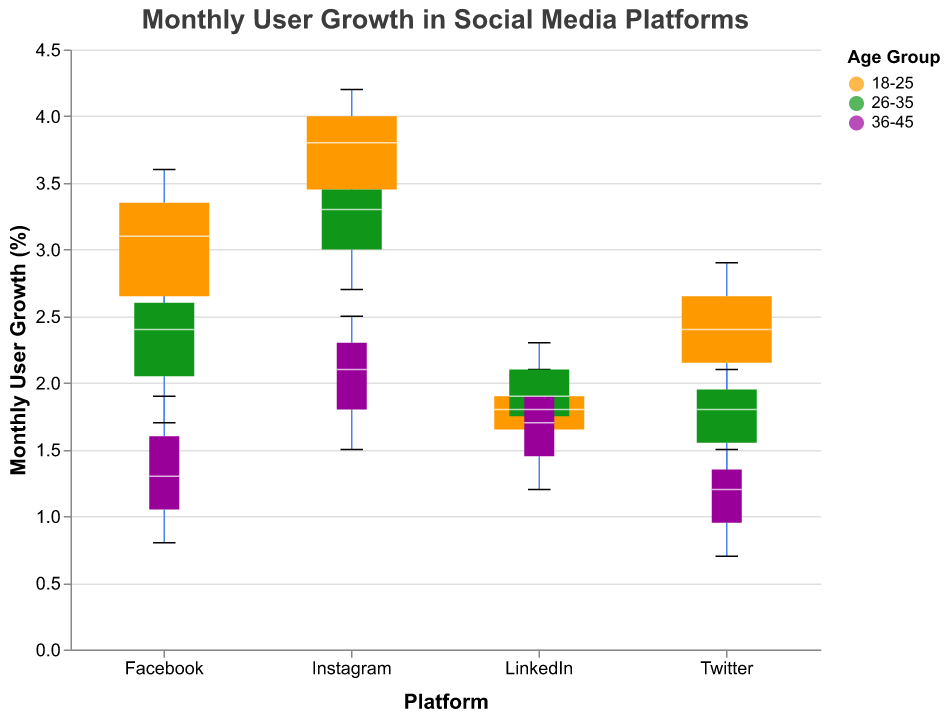What's the title of the figure? The title of the figure is usually displayed at the top. It is visually noticeable and meant to give a summary of what the plot presents.
Answer: Monthly User Growth in Social Media Platforms What does the y-axis represent? The y-axis usually shows the metric being measured, and in this figure, it is established by the axis title.
Answer: Monthly User Growth (%) Which age group shows the highest user growth on Instagram? By examining the highest points in the Instagram box plot, we compare the engagement levels and find that the "18-25" age group's high engagement has the maximum user growth.
Answer: 18-25 Compare the medium engagement levels for users aged 26-35 across all platforms. Which platform shows the highest user growth? We need to compare the monthly user growth for medium engagement levels in the 26-35 age group for all platforms. By looking at the plots, we see that Instagram has the highest user growth.
Answer: Instagram Which age group has the widest box plot in the figure, and what does it imply? A variable-width box plot's width shows the weight of data points for that category. By examining the widths of all box plots, we observe that the "18-25" age group has the widest plots, showing this age group has the most data points.
Answer: 18-25 For the LinkedIn platform, which engagement level shows the lowest monthly user growth within the 36-45 age group? By analyzing the LinkedIn box plot section for the 36-45 age group, the lowest user growth is seen in the low engagement level.
Answer: Low How does the median monthly user growth for high engagement levels compare across all age groups on Facebook? We need to compare the median lines in the Facebook box plots for high engagement levels in all age groups. The medians decrease from 3.6 (18-25), to 2.8 (26-35), and finally to 1.9 (36-45).
Answer: Decreasing with age Which age group and engagement level combination on Twitter has the closest range of monthly user growth? By looking at the box sizes for Twitter, the combination with the least range (smallest box size) is the 36-45 age group with low engagement.
Answer: 36-45, Low Is the variation in user growth for high engagement levels larger for Instagram or Facebook? The variation in a box plot is shown by the height of the box. By comparing the high engagement levels for both platforms, we see that Instagram's box is taller, indicating a larger variation.
Answer: Instagram Which age group on Facebook shows user growth below 1% in any engagement level? By examining the box plots for different ages on Facebook, we notice that the 36-45 age group has user growth below 1% for the low engagement level.
Answer: 36-45 